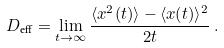Convert formula to latex. <formula><loc_0><loc_0><loc_500><loc_500>D _ { \text {eff} } = \lim _ { t \to \infty } \frac { \langle x ^ { 2 } ( t ) \rangle - \langle x ( t ) \rangle ^ { 2 } } { 2 t } \, .</formula> 